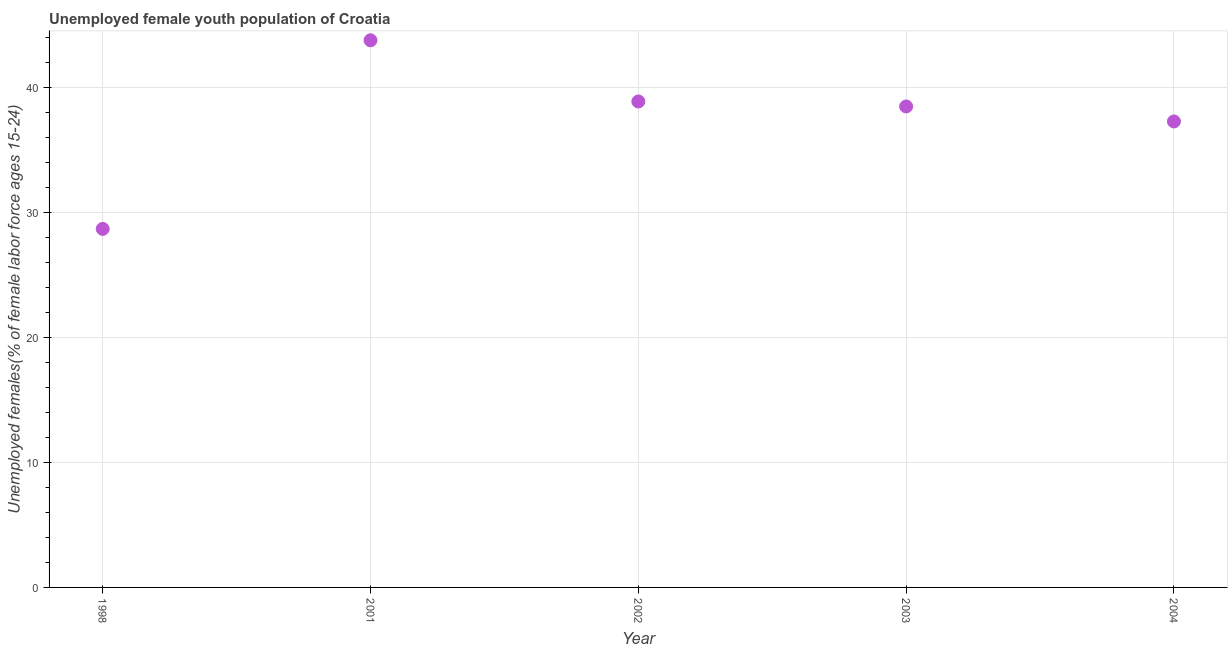What is the unemployed female youth in 2001?
Provide a succinct answer. 43.8. Across all years, what is the maximum unemployed female youth?
Ensure brevity in your answer.  43.8. Across all years, what is the minimum unemployed female youth?
Offer a terse response. 28.7. In which year was the unemployed female youth maximum?
Make the answer very short. 2001. In which year was the unemployed female youth minimum?
Your response must be concise. 1998. What is the sum of the unemployed female youth?
Ensure brevity in your answer.  187.2. What is the difference between the unemployed female youth in 1998 and 2002?
Provide a short and direct response. -10.2. What is the average unemployed female youth per year?
Give a very brief answer. 37.44. What is the median unemployed female youth?
Offer a terse response. 38.5. What is the ratio of the unemployed female youth in 2001 to that in 2004?
Your response must be concise. 1.17. Is the difference between the unemployed female youth in 2002 and 2003 greater than the difference between any two years?
Offer a very short reply. No. What is the difference between the highest and the second highest unemployed female youth?
Your answer should be compact. 4.9. Is the sum of the unemployed female youth in 1998 and 2002 greater than the maximum unemployed female youth across all years?
Your response must be concise. Yes. What is the difference between the highest and the lowest unemployed female youth?
Offer a very short reply. 15.1. Does the unemployed female youth monotonically increase over the years?
Your answer should be very brief. No. How many years are there in the graph?
Keep it short and to the point. 5. What is the difference between two consecutive major ticks on the Y-axis?
Provide a short and direct response. 10. Are the values on the major ticks of Y-axis written in scientific E-notation?
Your answer should be compact. No. Does the graph contain any zero values?
Ensure brevity in your answer.  No. Does the graph contain grids?
Provide a succinct answer. Yes. What is the title of the graph?
Offer a very short reply. Unemployed female youth population of Croatia. What is the label or title of the Y-axis?
Your answer should be very brief. Unemployed females(% of female labor force ages 15-24). What is the Unemployed females(% of female labor force ages 15-24) in 1998?
Your answer should be compact. 28.7. What is the Unemployed females(% of female labor force ages 15-24) in 2001?
Ensure brevity in your answer.  43.8. What is the Unemployed females(% of female labor force ages 15-24) in 2002?
Ensure brevity in your answer.  38.9. What is the Unemployed females(% of female labor force ages 15-24) in 2003?
Provide a short and direct response. 38.5. What is the Unemployed females(% of female labor force ages 15-24) in 2004?
Your response must be concise. 37.3. What is the difference between the Unemployed females(% of female labor force ages 15-24) in 1998 and 2001?
Offer a terse response. -15.1. What is the difference between the Unemployed females(% of female labor force ages 15-24) in 2001 and 2002?
Your answer should be compact. 4.9. What is the difference between the Unemployed females(% of female labor force ages 15-24) in 2001 and 2003?
Give a very brief answer. 5.3. What is the difference between the Unemployed females(% of female labor force ages 15-24) in 2002 and 2004?
Ensure brevity in your answer.  1.6. What is the difference between the Unemployed females(% of female labor force ages 15-24) in 2003 and 2004?
Ensure brevity in your answer.  1.2. What is the ratio of the Unemployed females(% of female labor force ages 15-24) in 1998 to that in 2001?
Provide a short and direct response. 0.66. What is the ratio of the Unemployed females(% of female labor force ages 15-24) in 1998 to that in 2002?
Provide a short and direct response. 0.74. What is the ratio of the Unemployed females(% of female labor force ages 15-24) in 1998 to that in 2003?
Make the answer very short. 0.74. What is the ratio of the Unemployed females(% of female labor force ages 15-24) in 1998 to that in 2004?
Provide a short and direct response. 0.77. What is the ratio of the Unemployed females(% of female labor force ages 15-24) in 2001 to that in 2002?
Your answer should be compact. 1.13. What is the ratio of the Unemployed females(% of female labor force ages 15-24) in 2001 to that in 2003?
Provide a succinct answer. 1.14. What is the ratio of the Unemployed females(% of female labor force ages 15-24) in 2001 to that in 2004?
Ensure brevity in your answer.  1.17. What is the ratio of the Unemployed females(% of female labor force ages 15-24) in 2002 to that in 2003?
Offer a terse response. 1.01. What is the ratio of the Unemployed females(% of female labor force ages 15-24) in 2002 to that in 2004?
Your answer should be very brief. 1.04. What is the ratio of the Unemployed females(% of female labor force ages 15-24) in 2003 to that in 2004?
Your answer should be compact. 1.03. 